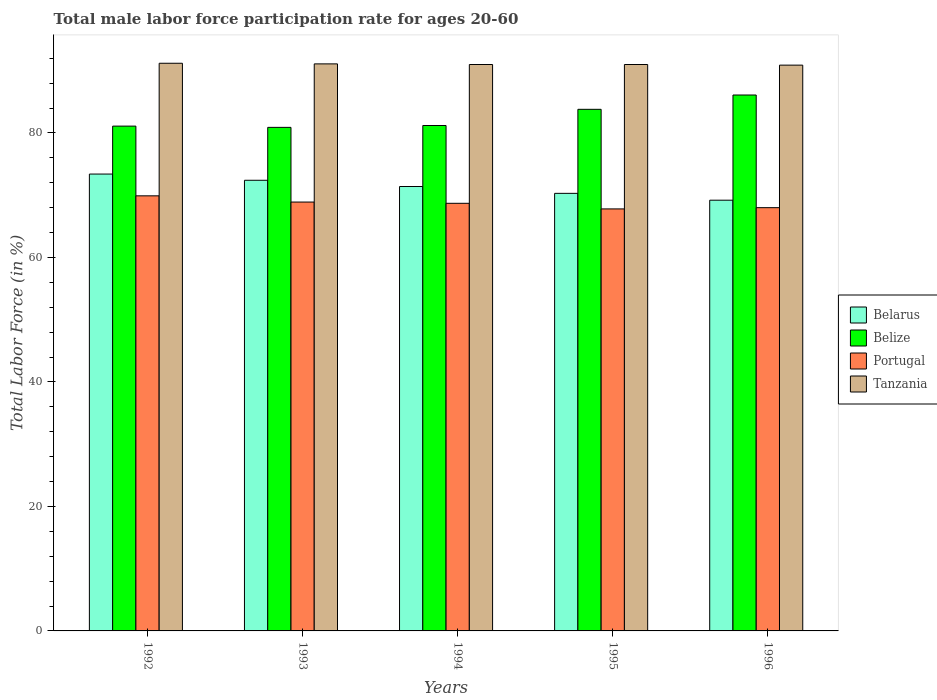How many different coloured bars are there?
Give a very brief answer. 4. How many groups of bars are there?
Make the answer very short. 5. Are the number of bars on each tick of the X-axis equal?
Ensure brevity in your answer.  Yes. How many bars are there on the 4th tick from the right?
Make the answer very short. 4. What is the label of the 3rd group of bars from the left?
Your answer should be very brief. 1994. What is the male labor force participation rate in Tanzania in 1992?
Ensure brevity in your answer.  91.2. Across all years, what is the maximum male labor force participation rate in Belize?
Provide a short and direct response. 86.1. Across all years, what is the minimum male labor force participation rate in Portugal?
Provide a succinct answer. 67.8. In which year was the male labor force participation rate in Belize maximum?
Make the answer very short. 1996. In which year was the male labor force participation rate in Tanzania minimum?
Provide a short and direct response. 1996. What is the total male labor force participation rate in Tanzania in the graph?
Your response must be concise. 455.2. What is the difference between the male labor force participation rate in Belize in 1992 and that in 1993?
Your answer should be very brief. 0.2. What is the difference between the male labor force participation rate in Portugal in 1992 and the male labor force participation rate in Tanzania in 1994?
Ensure brevity in your answer.  -21.1. What is the average male labor force participation rate in Tanzania per year?
Provide a short and direct response. 91.04. In the year 1995, what is the difference between the male labor force participation rate in Belize and male labor force participation rate in Belarus?
Provide a short and direct response. 13.5. What is the ratio of the male labor force participation rate in Belize in 1993 to that in 1995?
Your response must be concise. 0.97. Is the difference between the male labor force participation rate in Belize in 1993 and 1994 greater than the difference between the male labor force participation rate in Belarus in 1993 and 1994?
Give a very brief answer. No. What is the difference between the highest and the lowest male labor force participation rate in Portugal?
Provide a succinct answer. 2.1. Is the sum of the male labor force participation rate in Belarus in 1992 and 1994 greater than the maximum male labor force participation rate in Belize across all years?
Your response must be concise. Yes. What does the 1st bar from the left in 1994 represents?
Provide a short and direct response. Belarus. What does the 3rd bar from the right in 1992 represents?
Keep it short and to the point. Belize. Is it the case that in every year, the sum of the male labor force participation rate in Belize and male labor force participation rate in Belarus is greater than the male labor force participation rate in Tanzania?
Your answer should be compact. Yes. How many bars are there?
Your answer should be compact. 20. Are all the bars in the graph horizontal?
Offer a very short reply. No. How many years are there in the graph?
Keep it short and to the point. 5. What is the difference between two consecutive major ticks on the Y-axis?
Offer a terse response. 20. Does the graph contain any zero values?
Make the answer very short. No. Where does the legend appear in the graph?
Offer a very short reply. Center right. What is the title of the graph?
Your answer should be very brief. Total male labor force participation rate for ages 20-60. Does "Malta" appear as one of the legend labels in the graph?
Offer a very short reply. No. What is the label or title of the X-axis?
Your answer should be compact. Years. What is the label or title of the Y-axis?
Ensure brevity in your answer.  Total Labor Force (in %). What is the Total Labor Force (in %) in Belarus in 1992?
Ensure brevity in your answer.  73.4. What is the Total Labor Force (in %) of Belize in 1992?
Keep it short and to the point. 81.1. What is the Total Labor Force (in %) in Portugal in 1992?
Your answer should be very brief. 69.9. What is the Total Labor Force (in %) of Tanzania in 1992?
Make the answer very short. 91.2. What is the Total Labor Force (in %) in Belarus in 1993?
Provide a short and direct response. 72.4. What is the Total Labor Force (in %) in Belize in 1993?
Your answer should be very brief. 80.9. What is the Total Labor Force (in %) of Portugal in 1993?
Offer a terse response. 68.9. What is the Total Labor Force (in %) of Tanzania in 1993?
Offer a terse response. 91.1. What is the Total Labor Force (in %) of Belarus in 1994?
Your response must be concise. 71.4. What is the Total Labor Force (in %) of Belize in 1994?
Ensure brevity in your answer.  81.2. What is the Total Labor Force (in %) in Portugal in 1994?
Provide a succinct answer. 68.7. What is the Total Labor Force (in %) in Tanzania in 1994?
Give a very brief answer. 91. What is the Total Labor Force (in %) of Belarus in 1995?
Ensure brevity in your answer.  70.3. What is the Total Labor Force (in %) of Belize in 1995?
Keep it short and to the point. 83.8. What is the Total Labor Force (in %) in Portugal in 1995?
Keep it short and to the point. 67.8. What is the Total Labor Force (in %) of Tanzania in 1995?
Keep it short and to the point. 91. What is the Total Labor Force (in %) of Belarus in 1996?
Offer a terse response. 69.2. What is the Total Labor Force (in %) in Belize in 1996?
Keep it short and to the point. 86.1. What is the Total Labor Force (in %) in Portugal in 1996?
Provide a succinct answer. 68. What is the Total Labor Force (in %) of Tanzania in 1996?
Your answer should be very brief. 90.9. Across all years, what is the maximum Total Labor Force (in %) of Belarus?
Offer a terse response. 73.4. Across all years, what is the maximum Total Labor Force (in %) in Belize?
Provide a short and direct response. 86.1. Across all years, what is the maximum Total Labor Force (in %) of Portugal?
Give a very brief answer. 69.9. Across all years, what is the maximum Total Labor Force (in %) in Tanzania?
Ensure brevity in your answer.  91.2. Across all years, what is the minimum Total Labor Force (in %) in Belarus?
Offer a very short reply. 69.2. Across all years, what is the minimum Total Labor Force (in %) of Belize?
Your answer should be very brief. 80.9. Across all years, what is the minimum Total Labor Force (in %) of Portugal?
Keep it short and to the point. 67.8. Across all years, what is the minimum Total Labor Force (in %) in Tanzania?
Keep it short and to the point. 90.9. What is the total Total Labor Force (in %) in Belarus in the graph?
Provide a succinct answer. 356.7. What is the total Total Labor Force (in %) of Belize in the graph?
Your response must be concise. 413.1. What is the total Total Labor Force (in %) of Portugal in the graph?
Keep it short and to the point. 343.3. What is the total Total Labor Force (in %) of Tanzania in the graph?
Your response must be concise. 455.2. What is the difference between the Total Labor Force (in %) of Belize in 1992 and that in 1994?
Make the answer very short. -0.1. What is the difference between the Total Labor Force (in %) of Tanzania in 1992 and that in 1994?
Your answer should be very brief. 0.2. What is the difference between the Total Labor Force (in %) of Belarus in 1992 and that in 1995?
Provide a succinct answer. 3.1. What is the difference between the Total Labor Force (in %) in Belize in 1992 and that in 1995?
Your answer should be compact. -2.7. What is the difference between the Total Labor Force (in %) in Tanzania in 1992 and that in 1995?
Offer a terse response. 0.2. What is the difference between the Total Labor Force (in %) in Belarus in 1992 and that in 1996?
Give a very brief answer. 4.2. What is the difference between the Total Labor Force (in %) in Portugal in 1992 and that in 1996?
Offer a very short reply. 1.9. What is the difference between the Total Labor Force (in %) of Tanzania in 1993 and that in 1994?
Offer a very short reply. 0.1. What is the difference between the Total Labor Force (in %) in Belize in 1993 and that in 1995?
Give a very brief answer. -2.9. What is the difference between the Total Labor Force (in %) of Portugal in 1993 and that in 1995?
Ensure brevity in your answer.  1.1. What is the difference between the Total Labor Force (in %) of Belize in 1993 and that in 1996?
Ensure brevity in your answer.  -5.2. What is the difference between the Total Labor Force (in %) in Portugal in 1993 and that in 1996?
Your response must be concise. 0.9. What is the difference between the Total Labor Force (in %) in Tanzania in 1993 and that in 1996?
Offer a very short reply. 0.2. What is the difference between the Total Labor Force (in %) in Portugal in 1994 and that in 1995?
Provide a short and direct response. 0.9. What is the difference between the Total Labor Force (in %) of Belize in 1994 and that in 1996?
Your response must be concise. -4.9. What is the difference between the Total Labor Force (in %) of Tanzania in 1994 and that in 1996?
Make the answer very short. 0.1. What is the difference between the Total Labor Force (in %) in Belize in 1995 and that in 1996?
Your response must be concise. -2.3. What is the difference between the Total Labor Force (in %) of Portugal in 1995 and that in 1996?
Offer a very short reply. -0.2. What is the difference between the Total Labor Force (in %) of Tanzania in 1995 and that in 1996?
Provide a short and direct response. 0.1. What is the difference between the Total Labor Force (in %) of Belarus in 1992 and the Total Labor Force (in %) of Belize in 1993?
Offer a terse response. -7.5. What is the difference between the Total Labor Force (in %) in Belarus in 1992 and the Total Labor Force (in %) in Portugal in 1993?
Give a very brief answer. 4.5. What is the difference between the Total Labor Force (in %) in Belarus in 1992 and the Total Labor Force (in %) in Tanzania in 1993?
Offer a terse response. -17.7. What is the difference between the Total Labor Force (in %) of Portugal in 1992 and the Total Labor Force (in %) of Tanzania in 1993?
Offer a terse response. -21.2. What is the difference between the Total Labor Force (in %) in Belarus in 1992 and the Total Labor Force (in %) in Tanzania in 1994?
Make the answer very short. -17.6. What is the difference between the Total Labor Force (in %) of Belize in 1992 and the Total Labor Force (in %) of Portugal in 1994?
Offer a very short reply. 12.4. What is the difference between the Total Labor Force (in %) in Portugal in 1992 and the Total Labor Force (in %) in Tanzania in 1994?
Ensure brevity in your answer.  -21.1. What is the difference between the Total Labor Force (in %) in Belarus in 1992 and the Total Labor Force (in %) in Belize in 1995?
Your answer should be very brief. -10.4. What is the difference between the Total Labor Force (in %) of Belarus in 1992 and the Total Labor Force (in %) of Tanzania in 1995?
Give a very brief answer. -17.6. What is the difference between the Total Labor Force (in %) of Portugal in 1992 and the Total Labor Force (in %) of Tanzania in 1995?
Provide a short and direct response. -21.1. What is the difference between the Total Labor Force (in %) of Belarus in 1992 and the Total Labor Force (in %) of Belize in 1996?
Provide a short and direct response. -12.7. What is the difference between the Total Labor Force (in %) in Belarus in 1992 and the Total Labor Force (in %) in Tanzania in 1996?
Ensure brevity in your answer.  -17.5. What is the difference between the Total Labor Force (in %) of Belize in 1992 and the Total Labor Force (in %) of Portugal in 1996?
Ensure brevity in your answer.  13.1. What is the difference between the Total Labor Force (in %) in Portugal in 1992 and the Total Labor Force (in %) in Tanzania in 1996?
Your response must be concise. -21. What is the difference between the Total Labor Force (in %) of Belarus in 1993 and the Total Labor Force (in %) of Belize in 1994?
Provide a short and direct response. -8.8. What is the difference between the Total Labor Force (in %) of Belarus in 1993 and the Total Labor Force (in %) of Tanzania in 1994?
Your answer should be compact. -18.6. What is the difference between the Total Labor Force (in %) in Belize in 1993 and the Total Labor Force (in %) in Portugal in 1994?
Provide a short and direct response. 12.2. What is the difference between the Total Labor Force (in %) in Belize in 1993 and the Total Labor Force (in %) in Tanzania in 1994?
Your answer should be very brief. -10.1. What is the difference between the Total Labor Force (in %) of Portugal in 1993 and the Total Labor Force (in %) of Tanzania in 1994?
Your answer should be very brief. -22.1. What is the difference between the Total Labor Force (in %) of Belarus in 1993 and the Total Labor Force (in %) of Portugal in 1995?
Provide a succinct answer. 4.6. What is the difference between the Total Labor Force (in %) of Belarus in 1993 and the Total Labor Force (in %) of Tanzania in 1995?
Provide a succinct answer. -18.6. What is the difference between the Total Labor Force (in %) in Belize in 1993 and the Total Labor Force (in %) in Portugal in 1995?
Your answer should be compact. 13.1. What is the difference between the Total Labor Force (in %) of Portugal in 1993 and the Total Labor Force (in %) of Tanzania in 1995?
Provide a succinct answer. -22.1. What is the difference between the Total Labor Force (in %) in Belarus in 1993 and the Total Labor Force (in %) in Belize in 1996?
Offer a terse response. -13.7. What is the difference between the Total Labor Force (in %) of Belarus in 1993 and the Total Labor Force (in %) of Portugal in 1996?
Keep it short and to the point. 4.4. What is the difference between the Total Labor Force (in %) in Belarus in 1993 and the Total Labor Force (in %) in Tanzania in 1996?
Your answer should be compact. -18.5. What is the difference between the Total Labor Force (in %) of Belize in 1993 and the Total Labor Force (in %) of Portugal in 1996?
Your response must be concise. 12.9. What is the difference between the Total Labor Force (in %) in Portugal in 1993 and the Total Labor Force (in %) in Tanzania in 1996?
Your answer should be very brief. -22. What is the difference between the Total Labor Force (in %) in Belarus in 1994 and the Total Labor Force (in %) in Belize in 1995?
Your answer should be very brief. -12.4. What is the difference between the Total Labor Force (in %) of Belarus in 1994 and the Total Labor Force (in %) of Portugal in 1995?
Keep it short and to the point. 3.6. What is the difference between the Total Labor Force (in %) in Belarus in 1994 and the Total Labor Force (in %) in Tanzania in 1995?
Ensure brevity in your answer.  -19.6. What is the difference between the Total Labor Force (in %) in Belize in 1994 and the Total Labor Force (in %) in Portugal in 1995?
Make the answer very short. 13.4. What is the difference between the Total Labor Force (in %) of Belize in 1994 and the Total Labor Force (in %) of Tanzania in 1995?
Ensure brevity in your answer.  -9.8. What is the difference between the Total Labor Force (in %) in Portugal in 1994 and the Total Labor Force (in %) in Tanzania in 1995?
Keep it short and to the point. -22.3. What is the difference between the Total Labor Force (in %) in Belarus in 1994 and the Total Labor Force (in %) in Belize in 1996?
Offer a very short reply. -14.7. What is the difference between the Total Labor Force (in %) of Belarus in 1994 and the Total Labor Force (in %) of Portugal in 1996?
Keep it short and to the point. 3.4. What is the difference between the Total Labor Force (in %) in Belarus in 1994 and the Total Labor Force (in %) in Tanzania in 1996?
Your response must be concise. -19.5. What is the difference between the Total Labor Force (in %) in Belize in 1994 and the Total Labor Force (in %) in Portugal in 1996?
Offer a terse response. 13.2. What is the difference between the Total Labor Force (in %) of Portugal in 1994 and the Total Labor Force (in %) of Tanzania in 1996?
Your answer should be very brief. -22.2. What is the difference between the Total Labor Force (in %) in Belarus in 1995 and the Total Labor Force (in %) in Belize in 1996?
Provide a short and direct response. -15.8. What is the difference between the Total Labor Force (in %) in Belarus in 1995 and the Total Labor Force (in %) in Portugal in 1996?
Provide a short and direct response. 2.3. What is the difference between the Total Labor Force (in %) in Belarus in 1995 and the Total Labor Force (in %) in Tanzania in 1996?
Your answer should be very brief. -20.6. What is the difference between the Total Labor Force (in %) in Belize in 1995 and the Total Labor Force (in %) in Portugal in 1996?
Make the answer very short. 15.8. What is the difference between the Total Labor Force (in %) of Belize in 1995 and the Total Labor Force (in %) of Tanzania in 1996?
Offer a terse response. -7.1. What is the difference between the Total Labor Force (in %) of Portugal in 1995 and the Total Labor Force (in %) of Tanzania in 1996?
Provide a short and direct response. -23.1. What is the average Total Labor Force (in %) in Belarus per year?
Your response must be concise. 71.34. What is the average Total Labor Force (in %) of Belize per year?
Provide a succinct answer. 82.62. What is the average Total Labor Force (in %) of Portugal per year?
Your answer should be very brief. 68.66. What is the average Total Labor Force (in %) of Tanzania per year?
Give a very brief answer. 91.04. In the year 1992, what is the difference between the Total Labor Force (in %) in Belarus and Total Labor Force (in %) in Portugal?
Provide a succinct answer. 3.5. In the year 1992, what is the difference between the Total Labor Force (in %) in Belarus and Total Labor Force (in %) in Tanzania?
Make the answer very short. -17.8. In the year 1992, what is the difference between the Total Labor Force (in %) of Belize and Total Labor Force (in %) of Portugal?
Your answer should be very brief. 11.2. In the year 1992, what is the difference between the Total Labor Force (in %) of Belize and Total Labor Force (in %) of Tanzania?
Give a very brief answer. -10.1. In the year 1992, what is the difference between the Total Labor Force (in %) in Portugal and Total Labor Force (in %) in Tanzania?
Provide a short and direct response. -21.3. In the year 1993, what is the difference between the Total Labor Force (in %) of Belarus and Total Labor Force (in %) of Portugal?
Give a very brief answer. 3.5. In the year 1993, what is the difference between the Total Labor Force (in %) of Belarus and Total Labor Force (in %) of Tanzania?
Give a very brief answer. -18.7. In the year 1993, what is the difference between the Total Labor Force (in %) of Belize and Total Labor Force (in %) of Portugal?
Ensure brevity in your answer.  12. In the year 1993, what is the difference between the Total Labor Force (in %) of Belize and Total Labor Force (in %) of Tanzania?
Give a very brief answer. -10.2. In the year 1993, what is the difference between the Total Labor Force (in %) in Portugal and Total Labor Force (in %) in Tanzania?
Your answer should be compact. -22.2. In the year 1994, what is the difference between the Total Labor Force (in %) of Belarus and Total Labor Force (in %) of Portugal?
Your answer should be compact. 2.7. In the year 1994, what is the difference between the Total Labor Force (in %) of Belarus and Total Labor Force (in %) of Tanzania?
Ensure brevity in your answer.  -19.6. In the year 1994, what is the difference between the Total Labor Force (in %) in Belize and Total Labor Force (in %) in Portugal?
Your answer should be compact. 12.5. In the year 1994, what is the difference between the Total Labor Force (in %) of Portugal and Total Labor Force (in %) of Tanzania?
Give a very brief answer. -22.3. In the year 1995, what is the difference between the Total Labor Force (in %) of Belarus and Total Labor Force (in %) of Belize?
Ensure brevity in your answer.  -13.5. In the year 1995, what is the difference between the Total Labor Force (in %) in Belarus and Total Labor Force (in %) in Portugal?
Provide a short and direct response. 2.5. In the year 1995, what is the difference between the Total Labor Force (in %) in Belarus and Total Labor Force (in %) in Tanzania?
Keep it short and to the point. -20.7. In the year 1995, what is the difference between the Total Labor Force (in %) in Portugal and Total Labor Force (in %) in Tanzania?
Your answer should be very brief. -23.2. In the year 1996, what is the difference between the Total Labor Force (in %) of Belarus and Total Labor Force (in %) of Belize?
Offer a very short reply. -16.9. In the year 1996, what is the difference between the Total Labor Force (in %) of Belarus and Total Labor Force (in %) of Portugal?
Keep it short and to the point. 1.2. In the year 1996, what is the difference between the Total Labor Force (in %) of Belarus and Total Labor Force (in %) of Tanzania?
Give a very brief answer. -21.7. In the year 1996, what is the difference between the Total Labor Force (in %) of Belize and Total Labor Force (in %) of Tanzania?
Your answer should be compact. -4.8. In the year 1996, what is the difference between the Total Labor Force (in %) of Portugal and Total Labor Force (in %) of Tanzania?
Keep it short and to the point. -22.9. What is the ratio of the Total Labor Force (in %) in Belarus in 1992 to that in 1993?
Offer a terse response. 1.01. What is the ratio of the Total Labor Force (in %) of Portugal in 1992 to that in 1993?
Give a very brief answer. 1.01. What is the ratio of the Total Labor Force (in %) in Belarus in 1992 to that in 1994?
Make the answer very short. 1.03. What is the ratio of the Total Labor Force (in %) in Portugal in 1992 to that in 1994?
Give a very brief answer. 1.02. What is the ratio of the Total Labor Force (in %) in Belarus in 1992 to that in 1995?
Provide a short and direct response. 1.04. What is the ratio of the Total Labor Force (in %) in Belize in 1992 to that in 1995?
Your answer should be compact. 0.97. What is the ratio of the Total Labor Force (in %) in Portugal in 1992 to that in 1995?
Give a very brief answer. 1.03. What is the ratio of the Total Labor Force (in %) of Tanzania in 1992 to that in 1995?
Make the answer very short. 1. What is the ratio of the Total Labor Force (in %) of Belarus in 1992 to that in 1996?
Ensure brevity in your answer.  1.06. What is the ratio of the Total Labor Force (in %) of Belize in 1992 to that in 1996?
Your response must be concise. 0.94. What is the ratio of the Total Labor Force (in %) in Portugal in 1992 to that in 1996?
Provide a succinct answer. 1.03. What is the ratio of the Total Labor Force (in %) of Tanzania in 1992 to that in 1996?
Your response must be concise. 1. What is the ratio of the Total Labor Force (in %) of Portugal in 1993 to that in 1994?
Keep it short and to the point. 1. What is the ratio of the Total Labor Force (in %) in Tanzania in 1993 to that in 1994?
Offer a terse response. 1. What is the ratio of the Total Labor Force (in %) in Belarus in 1993 to that in 1995?
Give a very brief answer. 1.03. What is the ratio of the Total Labor Force (in %) of Belize in 1993 to that in 1995?
Make the answer very short. 0.97. What is the ratio of the Total Labor Force (in %) of Portugal in 1993 to that in 1995?
Offer a terse response. 1.02. What is the ratio of the Total Labor Force (in %) in Tanzania in 1993 to that in 1995?
Your answer should be compact. 1. What is the ratio of the Total Labor Force (in %) in Belarus in 1993 to that in 1996?
Give a very brief answer. 1.05. What is the ratio of the Total Labor Force (in %) in Belize in 1993 to that in 1996?
Provide a succinct answer. 0.94. What is the ratio of the Total Labor Force (in %) of Portugal in 1993 to that in 1996?
Make the answer very short. 1.01. What is the ratio of the Total Labor Force (in %) in Tanzania in 1993 to that in 1996?
Make the answer very short. 1. What is the ratio of the Total Labor Force (in %) in Belarus in 1994 to that in 1995?
Give a very brief answer. 1.02. What is the ratio of the Total Labor Force (in %) in Belize in 1994 to that in 1995?
Your answer should be compact. 0.97. What is the ratio of the Total Labor Force (in %) of Portugal in 1994 to that in 1995?
Keep it short and to the point. 1.01. What is the ratio of the Total Labor Force (in %) of Tanzania in 1994 to that in 1995?
Provide a short and direct response. 1. What is the ratio of the Total Labor Force (in %) of Belarus in 1994 to that in 1996?
Give a very brief answer. 1.03. What is the ratio of the Total Labor Force (in %) of Belize in 1994 to that in 1996?
Offer a very short reply. 0.94. What is the ratio of the Total Labor Force (in %) of Portugal in 1994 to that in 1996?
Provide a succinct answer. 1.01. What is the ratio of the Total Labor Force (in %) of Tanzania in 1994 to that in 1996?
Make the answer very short. 1. What is the ratio of the Total Labor Force (in %) in Belarus in 1995 to that in 1996?
Your response must be concise. 1.02. What is the ratio of the Total Labor Force (in %) of Belize in 1995 to that in 1996?
Offer a terse response. 0.97. What is the ratio of the Total Labor Force (in %) of Tanzania in 1995 to that in 1996?
Ensure brevity in your answer.  1. What is the difference between the highest and the second highest Total Labor Force (in %) of Belarus?
Your response must be concise. 1. What is the difference between the highest and the second highest Total Labor Force (in %) of Portugal?
Offer a terse response. 1. What is the difference between the highest and the second highest Total Labor Force (in %) in Tanzania?
Make the answer very short. 0.1. What is the difference between the highest and the lowest Total Labor Force (in %) in Portugal?
Offer a terse response. 2.1. What is the difference between the highest and the lowest Total Labor Force (in %) in Tanzania?
Give a very brief answer. 0.3. 